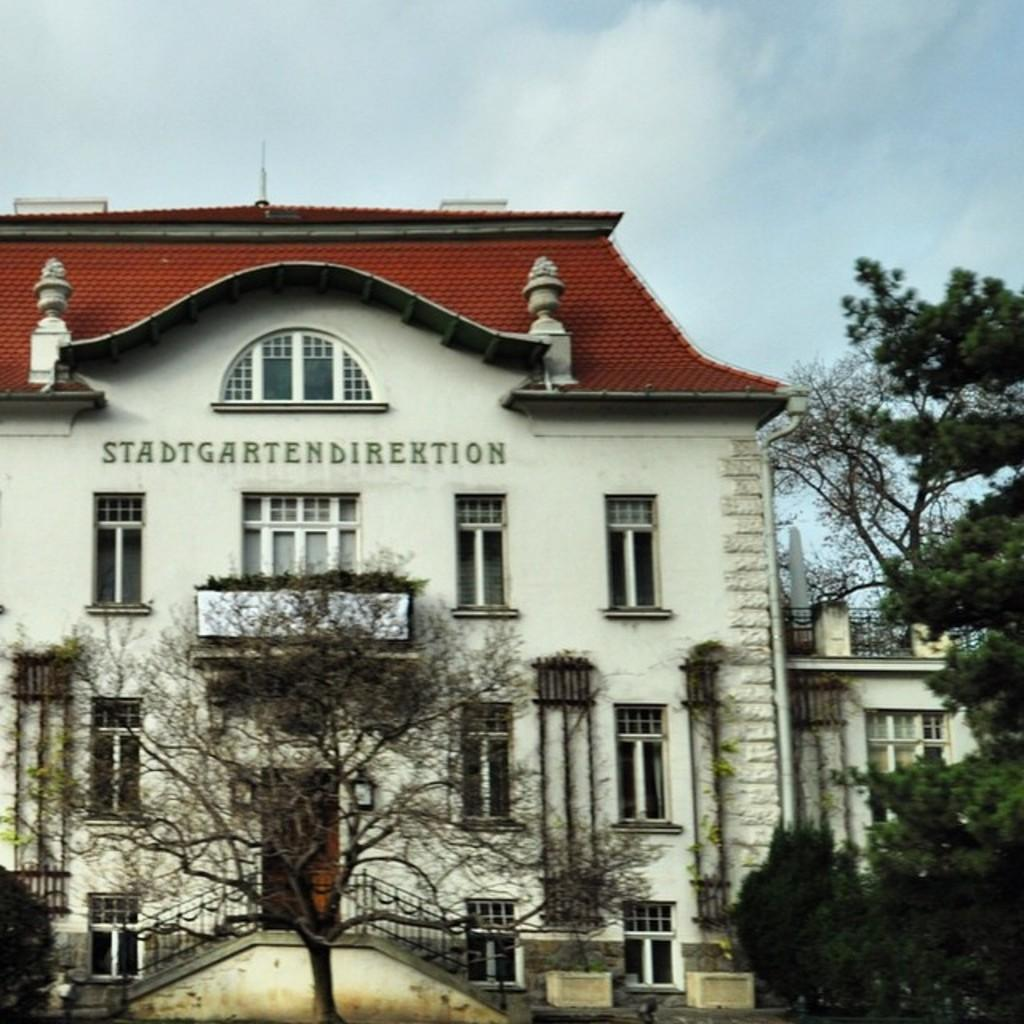What is the main subject of the picture? The main subject of the picture is a building. What can be seen in front of the building? Trees are present in front of the building. What is visible in the background of the image? There are clouds in the sky in the background of the image. What type of juice is being served in the building in the image? There is no indication of juice or any food or drink being served in the image. The focus is on the building, trees, and clouds. 